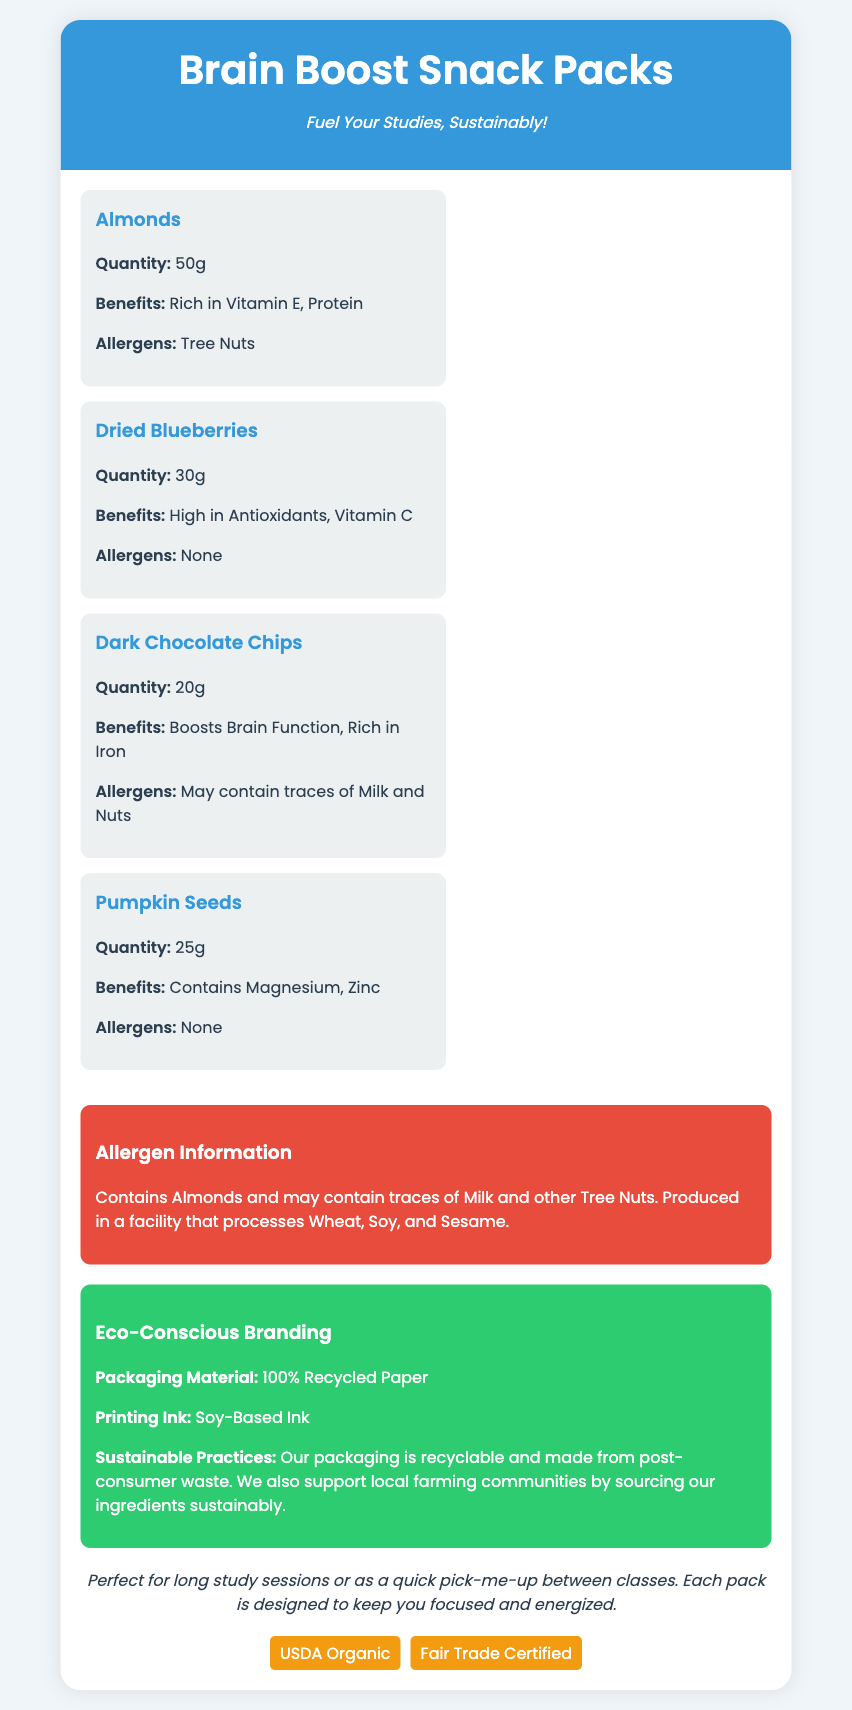What are the ingredients in the snack pack? The ingredients are listed in the document as Almonds, Dried Blueberries, Dark Chocolate Chips, and Pumpkin Seeds.
Answer: Almonds, Dried Blueberries, Dark Chocolate Chips, Pumpkin Seeds What is the quantity of Dried Blueberries? The quantity of Dried Blueberries is specified in the ingredient section.
Answer: 30g What allergens are present in the snack pack? Allergens are mentioned in the allergen information section, such as Almonds and potential traces of Milk and Nuts.
Answer: Almonds, Milk, Nuts What is the primary benefit of Dark Chocolate Chips? The benefits of Dark Chocolate Chips are stated in the ingredient section, focusing on brain function and iron content.
Answer: Boosts Brain Function, Rich in Iron What type of ink is used for printing? The document specifies the type of ink used for printing in the eco-conscious branding section.
Answer: Soy-Based Ink What is the total weight of Pumpkin Seeds? The weight of Pumpkin Seeds is given in the ingredient section.
Answer: 25g How is the packaging described in terms of recycling? The eco-conscious branding section mentions the recycling aspect of the packaging.
Answer: 100% Recycled Paper What certifications does the product have? The certifications are listed at the bottom of the document, reflecting its quality labels.
Answer: USDA Organic, Fair Trade Certified 